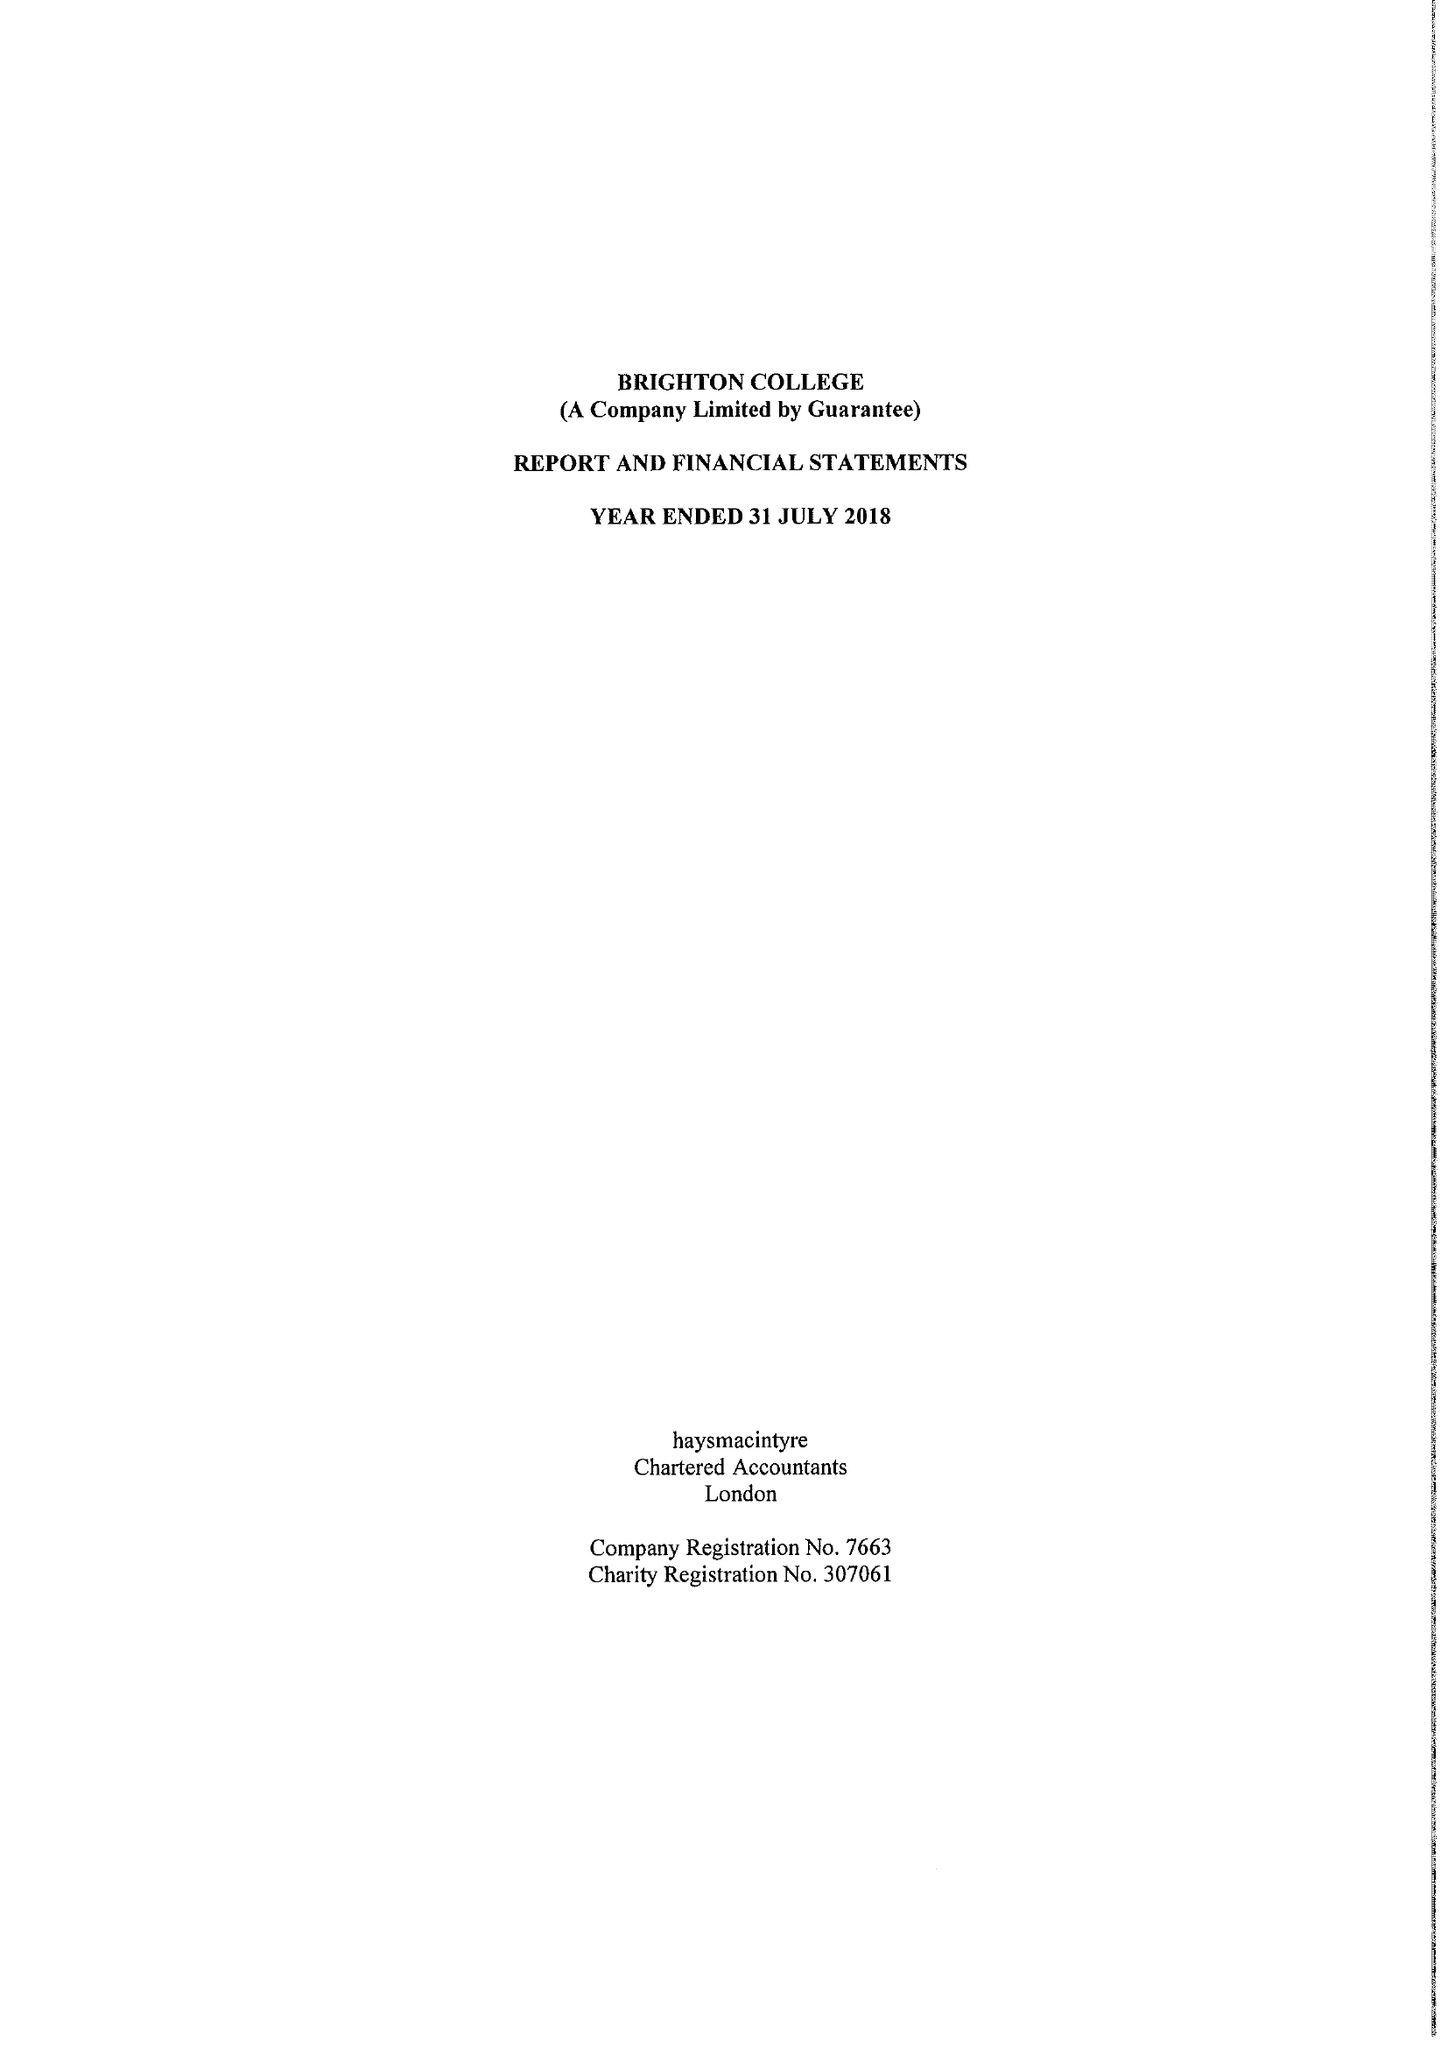What is the value for the charity_number?
Answer the question using a single word or phrase. 307061 